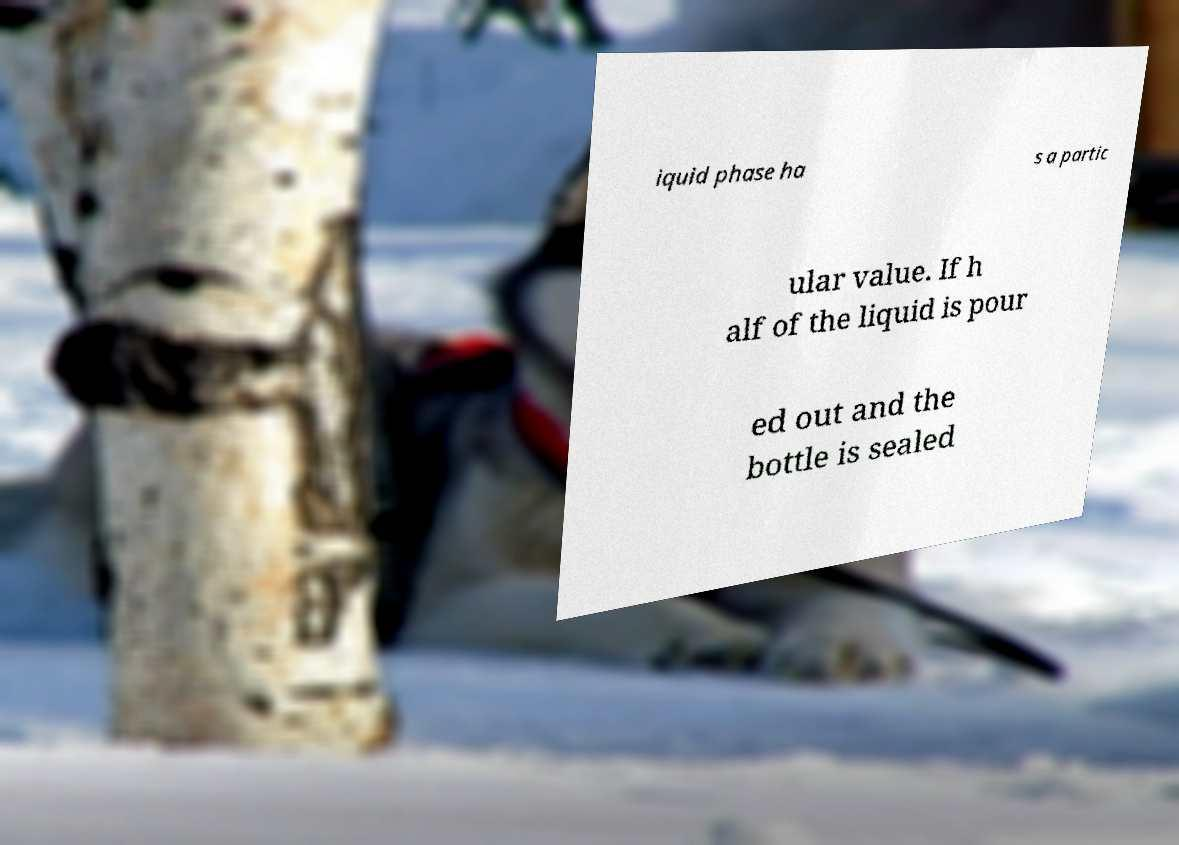Could you assist in decoding the text presented in this image and type it out clearly? iquid phase ha s a partic ular value. If h alf of the liquid is pour ed out and the bottle is sealed 